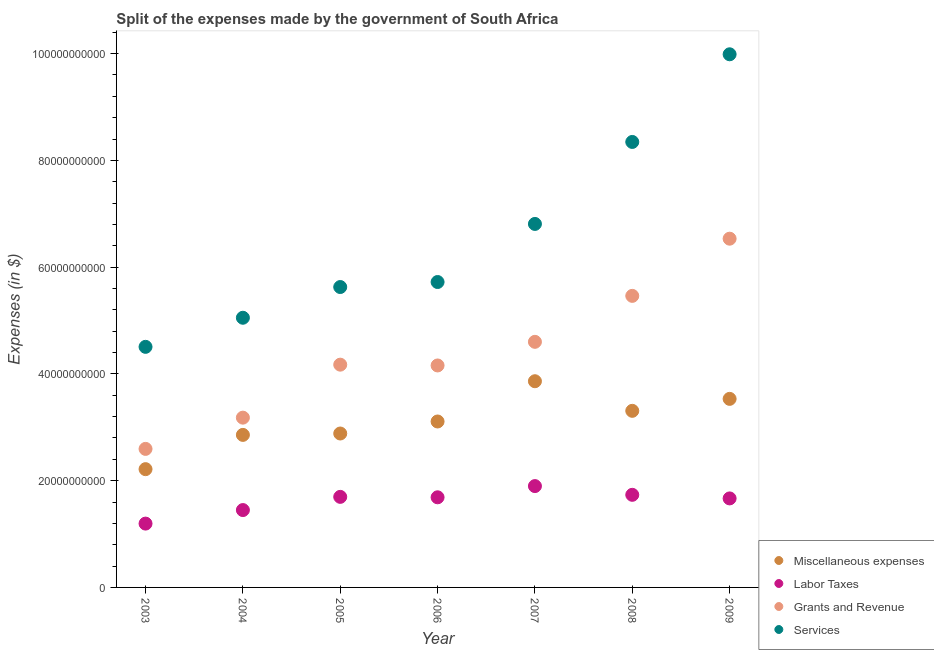How many different coloured dotlines are there?
Keep it short and to the point. 4. Is the number of dotlines equal to the number of legend labels?
Keep it short and to the point. Yes. What is the amount spent on miscellaneous expenses in 2005?
Keep it short and to the point. 2.88e+1. Across all years, what is the maximum amount spent on labor taxes?
Offer a terse response. 1.90e+1. Across all years, what is the minimum amount spent on labor taxes?
Make the answer very short. 1.20e+1. What is the total amount spent on grants and revenue in the graph?
Your answer should be very brief. 3.07e+11. What is the difference between the amount spent on labor taxes in 2004 and that in 2008?
Offer a terse response. -2.86e+09. What is the difference between the amount spent on miscellaneous expenses in 2003 and the amount spent on grants and revenue in 2004?
Offer a terse response. -9.65e+09. What is the average amount spent on services per year?
Offer a terse response. 6.58e+1. In the year 2005, what is the difference between the amount spent on grants and revenue and amount spent on services?
Your answer should be compact. -1.45e+1. In how many years, is the amount spent on grants and revenue greater than 64000000000 $?
Provide a short and direct response. 1. What is the ratio of the amount spent on grants and revenue in 2008 to that in 2009?
Ensure brevity in your answer.  0.84. What is the difference between the highest and the second highest amount spent on miscellaneous expenses?
Provide a short and direct response. 3.30e+09. What is the difference between the highest and the lowest amount spent on miscellaneous expenses?
Keep it short and to the point. 1.65e+1. Is the sum of the amount spent on miscellaneous expenses in 2003 and 2006 greater than the maximum amount spent on labor taxes across all years?
Keep it short and to the point. Yes. Is it the case that in every year, the sum of the amount spent on miscellaneous expenses and amount spent on labor taxes is greater than the amount spent on grants and revenue?
Give a very brief answer. No. Does the amount spent on labor taxes monotonically increase over the years?
Provide a succinct answer. No. Is the amount spent on services strictly greater than the amount spent on grants and revenue over the years?
Provide a succinct answer. Yes. Is the amount spent on labor taxes strictly less than the amount spent on services over the years?
Make the answer very short. Yes. How many dotlines are there?
Your answer should be very brief. 4. How many years are there in the graph?
Ensure brevity in your answer.  7. Does the graph contain any zero values?
Keep it short and to the point. No. Does the graph contain grids?
Keep it short and to the point. No. Where does the legend appear in the graph?
Your answer should be very brief. Bottom right. How many legend labels are there?
Your answer should be very brief. 4. How are the legend labels stacked?
Your response must be concise. Vertical. What is the title of the graph?
Make the answer very short. Split of the expenses made by the government of South Africa. What is the label or title of the X-axis?
Provide a short and direct response. Year. What is the label or title of the Y-axis?
Provide a succinct answer. Expenses (in $). What is the Expenses (in $) in Miscellaneous expenses in 2003?
Ensure brevity in your answer.  2.22e+1. What is the Expenses (in $) in Labor Taxes in 2003?
Offer a terse response. 1.20e+1. What is the Expenses (in $) of Grants and Revenue in 2003?
Give a very brief answer. 2.60e+1. What is the Expenses (in $) of Services in 2003?
Your answer should be compact. 4.51e+1. What is the Expenses (in $) in Miscellaneous expenses in 2004?
Your answer should be very brief. 2.86e+1. What is the Expenses (in $) of Labor Taxes in 2004?
Offer a very short reply. 1.45e+1. What is the Expenses (in $) in Grants and Revenue in 2004?
Your answer should be very brief. 3.18e+1. What is the Expenses (in $) of Services in 2004?
Your answer should be compact. 5.05e+1. What is the Expenses (in $) in Miscellaneous expenses in 2005?
Provide a short and direct response. 2.88e+1. What is the Expenses (in $) of Labor Taxes in 2005?
Ensure brevity in your answer.  1.70e+1. What is the Expenses (in $) in Grants and Revenue in 2005?
Provide a short and direct response. 4.17e+1. What is the Expenses (in $) in Services in 2005?
Your answer should be compact. 5.63e+1. What is the Expenses (in $) in Miscellaneous expenses in 2006?
Give a very brief answer. 3.11e+1. What is the Expenses (in $) in Labor Taxes in 2006?
Give a very brief answer. 1.69e+1. What is the Expenses (in $) of Grants and Revenue in 2006?
Your answer should be very brief. 4.16e+1. What is the Expenses (in $) in Services in 2006?
Give a very brief answer. 5.72e+1. What is the Expenses (in $) in Miscellaneous expenses in 2007?
Offer a very short reply. 3.86e+1. What is the Expenses (in $) in Labor Taxes in 2007?
Offer a very short reply. 1.90e+1. What is the Expenses (in $) in Grants and Revenue in 2007?
Your answer should be compact. 4.60e+1. What is the Expenses (in $) in Services in 2007?
Provide a short and direct response. 6.81e+1. What is the Expenses (in $) of Miscellaneous expenses in 2008?
Offer a terse response. 3.31e+1. What is the Expenses (in $) in Labor Taxes in 2008?
Provide a succinct answer. 1.73e+1. What is the Expenses (in $) of Grants and Revenue in 2008?
Give a very brief answer. 5.46e+1. What is the Expenses (in $) in Services in 2008?
Ensure brevity in your answer.  8.35e+1. What is the Expenses (in $) of Miscellaneous expenses in 2009?
Your answer should be compact. 3.53e+1. What is the Expenses (in $) of Labor Taxes in 2009?
Provide a short and direct response. 1.67e+1. What is the Expenses (in $) of Grants and Revenue in 2009?
Your response must be concise. 6.53e+1. What is the Expenses (in $) in Services in 2009?
Your answer should be very brief. 9.99e+1. Across all years, what is the maximum Expenses (in $) of Miscellaneous expenses?
Provide a short and direct response. 3.86e+1. Across all years, what is the maximum Expenses (in $) in Labor Taxes?
Provide a succinct answer. 1.90e+1. Across all years, what is the maximum Expenses (in $) in Grants and Revenue?
Your answer should be compact. 6.53e+1. Across all years, what is the maximum Expenses (in $) of Services?
Offer a terse response. 9.99e+1. Across all years, what is the minimum Expenses (in $) of Miscellaneous expenses?
Keep it short and to the point. 2.22e+1. Across all years, what is the minimum Expenses (in $) of Labor Taxes?
Ensure brevity in your answer.  1.20e+1. Across all years, what is the minimum Expenses (in $) of Grants and Revenue?
Offer a terse response. 2.60e+1. Across all years, what is the minimum Expenses (in $) in Services?
Offer a very short reply. 4.51e+1. What is the total Expenses (in $) of Miscellaneous expenses in the graph?
Provide a short and direct response. 2.18e+11. What is the total Expenses (in $) in Labor Taxes in the graph?
Your answer should be very brief. 1.13e+11. What is the total Expenses (in $) of Grants and Revenue in the graph?
Your response must be concise. 3.07e+11. What is the total Expenses (in $) of Services in the graph?
Your response must be concise. 4.61e+11. What is the difference between the Expenses (in $) in Miscellaneous expenses in 2003 and that in 2004?
Provide a short and direct response. -6.42e+09. What is the difference between the Expenses (in $) in Labor Taxes in 2003 and that in 2004?
Ensure brevity in your answer.  -2.54e+09. What is the difference between the Expenses (in $) of Grants and Revenue in 2003 and that in 2004?
Your answer should be compact. -5.85e+09. What is the difference between the Expenses (in $) of Services in 2003 and that in 2004?
Your answer should be very brief. -5.45e+09. What is the difference between the Expenses (in $) of Miscellaneous expenses in 2003 and that in 2005?
Offer a very short reply. -6.68e+09. What is the difference between the Expenses (in $) in Labor Taxes in 2003 and that in 2005?
Keep it short and to the point. -5.01e+09. What is the difference between the Expenses (in $) of Grants and Revenue in 2003 and that in 2005?
Provide a succinct answer. -1.58e+1. What is the difference between the Expenses (in $) of Services in 2003 and that in 2005?
Provide a short and direct response. -1.12e+1. What is the difference between the Expenses (in $) in Miscellaneous expenses in 2003 and that in 2006?
Provide a succinct answer. -8.93e+09. What is the difference between the Expenses (in $) of Labor Taxes in 2003 and that in 2006?
Your answer should be compact. -4.93e+09. What is the difference between the Expenses (in $) in Grants and Revenue in 2003 and that in 2006?
Ensure brevity in your answer.  -1.56e+1. What is the difference between the Expenses (in $) in Services in 2003 and that in 2006?
Keep it short and to the point. -1.21e+1. What is the difference between the Expenses (in $) in Miscellaneous expenses in 2003 and that in 2007?
Ensure brevity in your answer.  -1.65e+1. What is the difference between the Expenses (in $) in Labor Taxes in 2003 and that in 2007?
Keep it short and to the point. -7.03e+09. What is the difference between the Expenses (in $) of Grants and Revenue in 2003 and that in 2007?
Give a very brief answer. -2.01e+1. What is the difference between the Expenses (in $) of Services in 2003 and that in 2007?
Make the answer very short. -2.30e+1. What is the difference between the Expenses (in $) in Miscellaneous expenses in 2003 and that in 2008?
Ensure brevity in your answer.  -1.09e+1. What is the difference between the Expenses (in $) in Labor Taxes in 2003 and that in 2008?
Provide a succinct answer. -5.39e+09. What is the difference between the Expenses (in $) in Grants and Revenue in 2003 and that in 2008?
Offer a very short reply. -2.87e+1. What is the difference between the Expenses (in $) in Services in 2003 and that in 2008?
Your answer should be compact. -3.84e+1. What is the difference between the Expenses (in $) of Miscellaneous expenses in 2003 and that in 2009?
Give a very brief answer. -1.32e+1. What is the difference between the Expenses (in $) of Labor Taxes in 2003 and that in 2009?
Make the answer very short. -4.72e+09. What is the difference between the Expenses (in $) in Grants and Revenue in 2003 and that in 2009?
Ensure brevity in your answer.  -3.94e+1. What is the difference between the Expenses (in $) of Services in 2003 and that in 2009?
Your answer should be compact. -5.48e+1. What is the difference between the Expenses (in $) in Miscellaneous expenses in 2004 and that in 2005?
Make the answer very short. -2.61e+08. What is the difference between the Expenses (in $) in Labor Taxes in 2004 and that in 2005?
Offer a terse response. -2.47e+09. What is the difference between the Expenses (in $) of Grants and Revenue in 2004 and that in 2005?
Give a very brief answer. -9.93e+09. What is the difference between the Expenses (in $) of Services in 2004 and that in 2005?
Offer a very short reply. -5.76e+09. What is the difference between the Expenses (in $) in Miscellaneous expenses in 2004 and that in 2006?
Provide a short and direct response. -2.51e+09. What is the difference between the Expenses (in $) in Labor Taxes in 2004 and that in 2006?
Keep it short and to the point. -2.39e+09. What is the difference between the Expenses (in $) in Grants and Revenue in 2004 and that in 2006?
Offer a terse response. -9.78e+09. What is the difference between the Expenses (in $) in Services in 2004 and that in 2006?
Your answer should be compact. -6.70e+09. What is the difference between the Expenses (in $) in Miscellaneous expenses in 2004 and that in 2007?
Your answer should be compact. -1.01e+1. What is the difference between the Expenses (in $) of Labor Taxes in 2004 and that in 2007?
Your answer should be very brief. -4.49e+09. What is the difference between the Expenses (in $) of Grants and Revenue in 2004 and that in 2007?
Your answer should be compact. -1.42e+1. What is the difference between the Expenses (in $) of Services in 2004 and that in 2007?
Provide a succinct answer. -1.76e+1. What is the difference between the Expenses (in $) in Miscellaneous expenses in 2004 and that in 2008?
Your answer should be compact. -4.51e+09. What is the difference between the Expenses (in $) in Labor Taxes in 2004 and that in 2008?
Give a very brief answer. -2.86e+09. What is the difference between the Expenses (in $) of Grants and Revenue in 2004 and that in 2008?
Offer a very short reply. -2.28e+1. What is the difference between the Expenses (in $) of Services in 2004 and that in 2008?
Provide a short and direct response. -3.29e+1. What is the difference between the Expenses (in $) of Miscellaneous expenses in 2004 and that in 2009?
Your answer should be compact. -6.75e+09. What is the difference between the Expenses (in $) of Labor Taxes in 2004 and that in 2009?
Your response must be concise. -2.18e+09. What is the difference between the Expenses (in $) of Grants and Revenue in 2004 and that in 2009?
Provide a short and direct response. -3.35e+1. What is the difference between the Expenses (in $) of Services in 2004 and that in 2009?
Provide a succinct answer. -4.94e+1. What is the difference between the Expenses (in $) in Miscellaneous expenses in 2005 and that in 2006?
Offer a very short reply. -2.25e+09. What is the difference between the Expenses (in $) of Labor Taxes in 2005 and that in 2006?
Provide a succinct answer. 8.20e+07. What is the difference between the Expenses (in $) of Grants and Revenue in 2005 and that in 2006?
Your answer should be very brief. 1.50e+08. What is the difference between the Expenses (in $) in Services in 2005 and that in 2006?
Make the answer very short. -9.39e+08. What is the difference between the Expenses (in $) of Miscellaneous expenses in 2005 and that in 2007?
Your response must be concise. -9.79e+09. What is the difference between the Expenses (in $) in Labor Taxes in 2005 and that in 2007?
Your answer should be very brief. -2.02e+09. What is the difference between the Expenses (in $) of Grants and Revenue in 2005 and that in 2007?
Keep it short and to the point. -4.28e+09. What is the difference between the Expenses (in $) of Services in 2005 and that in 2007?
Offer a terse response. -1.18e+1. What is the difference between the Expenses (in $) of Miscellaneous expenses in 2005 and that in 2008?
Offer a terse response. -4.25e+09. What is the difference between the Expenses (in $) in Labor Taxes in 2005 and that in 2008?
Keep it short and to the point. -3.83e+08. What is the difference between the Expenses (in $) of Grants and Revenue in 2005 and that in 2008?
Provide a short and direct response. -1.29e+1. What is the difference between the Expenses (in $) in Services in 2005 and that in 2008?
Provide a succinct answer. -2.72e+1. What is the difference between the Expenses (in $) in Miscellaneous expenses in 2005 and that in 2009?
Keep it short and to the point. -6.49e+09. What is the difference between the Expenses (in $) of Labor Taxes in 2005 and that in 2009?
Make the answer very short. 2.91e+08. What is the difference between the Expenses (in $) in Grants and Revenue in 2005 and that in 2009?
Provide a succinct answer. -2.36e+1. What is the difference between the Expenses (in $) in Services in 2005 and that in 2009?
Offer a very short reply. -4.36e+1. What is the difference between the Expenses (in $) of Miscellaneous expenses in 2006 and that in 2007?
Your answer should be very brief. -7.54e+09. What is the difference between the Expenses (in $) of Labor Taxes in 2006 and that in 2007?
Provide a short and direct response. -2.10e+09. What is the difference between the Expenses (in $) of Grants and Revenue in 2006 and that in 2007?
Provide a short and direct response. -4.43e+09. What is the difference between the Expenses (in $) in Services in 2006 and that in 2007?
Keep it short and to the point. -1.09e+1. What is the difference between the Expenses (in $) of Miscellaneous expenses in 2006 and that in 2008?
Your response must be concise. -2.00e+09. What is the difference between the Expenses (in $) in Labor Taxes in 2006 and that in 2008?
Provide a succinct answer. -4.65e+08. What is the difference between the Expenses (in $) of Grants and Revenue in 2006 and that in 2008?
Your answer should be compact. -1.30e+1. What is the difference between the Expenses (in $) in Services in 2006 and that in 2008?
Ensure brevity in your answer.  -2.62e+1. What is the difference between the Expenses (in $) in Miscellaneous expenses in 2006 and that in 2009?
Give a very brief answer. -4.24e+09. What is the difference between the Expenses (in $) of Labor Taxes in 2006 and that in 2009?
Offer a very short reply. 2.09e+08. What is the difference between the Expenses (in $) of Grants and Revenue in 2006 and that in 2009?
Your answer should be compact. -2.37e+1. What is the difference between the Expenses (in $) in Services in 2006 and that in 2009?
Your response must be concise. -4.27e+1. What is the difference between the Expenses (in $) in Miscellaneous expenses in 2007 and that in 2008?
Ensure brevity in your answer.  5.55e+09. What is the difference between the Expenses (in $) in Labor Taxes in 2007 and that in 2008?
Keep it short and to the point. 1.64e+09. What is the difference between the Expenses (in $) in Grants and Revenue in 2007 and that in 2008?
Ensure brevity in your answer.  -8.61e+09. What is the difference between the Expenses (in $) of Services in 2007 and that in 2008?
Offer a terse response. -1.54e+1. What is the difference between the Expenses (in $) in Miscellaneous expenses in 2007 and that in 2009?
Your response must be concise. 3.30e+09. What is the difference between the Expenses (in $) of Labor Taxes in 2007 and that in 2009?
Offer a very short reply. 2.31e+09. What is the difference between the Expenses (in $) of Grants and Revenue in 2007 and that in 2009?
Provide a succinct answer. -1.93e+1. What is the difference between the Expenses (in $) of Services in 2007 and that in 2009?
Offer a very short reply. -3.18e+1. What is the difference between the Expenses (in $) in Miscellaneous expenses in 2008 and that in 2009?
Your answer should be compact. -2.24e+09. What is the difference between the Expenses (in $) in Labor Taxes in 2008 and that in 2009?
Your response must be concise. 6.74e+08. What is the difference between the Expenses (in $) of Grants and Revenue in 2008 and that in 2009?
Provide a succinct answer. -1.07e+1. What is the difference between the Expenses (in $) of Services in 2008 and that in 2009?
Provide a succinct answer. -1.64e+1. What is the difference between the Expenses (in $) in Miscellaneous expenses in 2003 and the Expenses (in $) in Labor Taxes in 2004?
Your answer should be very brief. 7.66e+09. What is the difference between the Expenses (in $) in Miscellaneous expenses in 2003 and the Expenses (in $) in Grants and Revenue in 2004?
Ensure brevity in your answer.  -9.65e+09. What is the difference between the Expenses (in $) in Miscellaneous expenses in 2003 and the Expenses (in $) in Services in 2004?
Give a very brief answer. -2.84e+1. What is the difference between the Expenses (in $) of Labor Taxes in 2003 and the Expenses (in $) of Grants and Revenue in 2004?
Offer a terse response. -1.98e+1. What is the difference between the Expenses (in $) in Labor Taxes in 2003 and the Expenses (in $) in Services in 2004?
Make the answer very short. -3.86e+1. What is the difference between the Expenses (in $) in Grants and Revenue in 2003 and the Expenses (in $) in Services in 2004?
Make the answer very short. -2.46e+1. What is the difference between the Expenses (in $) in Miscellaneous expenses in 2003 and the Expenses (in $) in Labor Taxes in 2005?
Your answer should be compact. 5.19e+09. What is the difference between the Expenses (in $) of Miscellaneous expenses in 2003 and the Expenses (in $) of Grants and Revenue in 2005?
Keep it short and to the point. -1.96e+1. What is the difference between the Expenses (in $) of Miscellaneous expenses in 2003 and the Expenses (in $) of Services in 2005?
Your response must be concise. -3.41e+1. What is the difference between the Expenses (in $) of Labor Taxes in 2003 and the Expenses (in $) of Grants and Revenue in 2005?
Keep it short and to the point. -2.98e+1. What is the difference between the Expenses (in $) in Labor Taxes in 2003 and the Expenses (in $) in Services in 2005?
Your answer should be compact. -4.43e+1. What is the difference between the Expenses (in $) in Grants and Revenue in 2003 and the Expenses (in $) in Services in 2005?
Keep it short and to the point. -3.03e+1. What is the difference between the Expenses (in $) of Miscellaneous expenses in 2003 and the Expenses (in $) of Labor Taxes in 2006?
Make the answer very short. 5.27e+09. What is the difference between the Expenses (in $) of Miscellaneous expenses in 2003 and the Expenses (in $) of Grants and Revenue in 2006?
Your answer should be very brief. -1.94e+1. What is the difference between the Expenses (in $) in Miscellaneous expenses in 2003 and the Expenses (in $) in Services in 2006?
Your response must be concise. -3.51e+1. What is the difference between the Expenses (in $) of Labor Taxes in 2003 and the Expenses (in $) of Grants and Revenue in 2006?
Ensure brevity in your answer.  -2.96e+1. What is the difference between the Expenses (in $) of Labor Taxes in 2003 and the Expenses (in $) of Services in 2006?
Keep it short and to the point. -4.53e+1. What is the difference between the Expenses (in $) in Grants and Revenue in 2003 and the Expenses (in $) in Services in 2006?
Your answer should be very brief. -3.13e+1. What is the difference between the Expenses (in $) of Miscellaneous expenses in 2003 and the Expenses (in $) of Labor Taxes in 2007?
Your response must be concise. 3.17e+09. What is the difference between the Expenses (in $) of Miscellaneous expenses in 2003 and the Expenses (in $) of Grants and Revenue in 2007?
Your answer should be very brief. -2.39e+1. What is the difference between the Expenses (in $) in Miscellaneous expenses in 2003 and the Expenses (in $) in Services in 2007?
Make the answer very short. -4.59e+1. What is the difference between the Expenses (in $) of Labor Taxes in 2003 and the Expenses (in $) of Grants and Revenue in 2007?
Keep it short and to the point. -3.41e+1. What is the difference between the Expenses (in $) in Labor Taxes in 2003 and the Expenses (in $) in Services in 2007?
Your response must be concise. -5.61e+1. What is the difference between the Expenses (in $) of Grants and Revenue in 2003 and the Expenses (in $) of Services in 2007?
Ensure brevity in your answer.  -4.21e+1. What is the difference between the Expenses (in $) in Miscellaneous expenses in 2003 and the Expenses (in $) in Labor Taxes in 2008?
Provide a succinct answer. 4.81e+09. What is the difference between the Expenses (in $) in Miscellaneous expenses in 2003 and the Expenses (in $) in Grants and Revenue in 2008?
Keep it short and to the point. -3.25e+1. What is the difference between the Expenses (in $) in Miscellaneous expenses in 2003 and the Expenses (in $) in Services in 2008?
Ensure brevity in your answer.  -6.13e+1. What is the difference between the Expenses (in $) in Labor Taxes in 2003 and the Expenses (in $) in Grants and Revenue in 2008?
Your response must be concise. -4.27e+1. What is the difference between the Expenses (in $) of Labor Taxes in 2003 and the Expenses (in $) of Services in 2008?
Ensure brevity in your answer.  -7.15e+1. What is the difference between the Expenses (in $) in Grants and Revenue in 2003 and the Expenses (in $) in Services in 2008?
Your answer should be very brief. -5.75e+1. What is the difference between the Expenses (in $) in Miscellaneous expenses in 2003 and the Expenses (in $) in Labor Taxes in 2009?
Provide a succinct answer. 5.48e+09. What is the difference between the Expenses (in $) of Miscellaneous expenses in 2003 and the Expenses (in $) of Grants and Revenue in 2009?
Ensure brevity in your answer.  -4.32e+1. What is the difference between the Expenses (in $) of Miscellaneous expenses in 2003 and the Expenses (in $) of Services in 2009?
Ensure brevity in your answer.  -7.77e+1. What is the difference between the Expenses (in $) in Labor Taxes in 2003 and the Expenses (in $) in Grants and Revenue in 2009?
Provide a succinct answer. -5.34e+1. What is the difference between the Expenses (in $) in Labor Taxes in 2003 and the Expenses (in $) in Services in 2009?
Give a very brief answer. -8.79e+1. What is the difference between the Expenses (in $) in Grants and Revenue in 2003 and the Expenses (in $) in Services in 2009?
Your response must be concise. -7.39e+1. What is the difference between the Expenses (in $) of Miscellaneous expenses in 2004 and the Expenses (in $) of Labor Taxes in 2005?
Your response must be concise. 1.16e+1. What is the difference between the Expenses (in $) in Miscellaneous expenses in 2004 and the Expenses (in $) in Grants and Revenue in 2005?
Your response must be concise. -1.32e+1. What is the difference between the Expenses (in $) in Miscellaneous expenses in 2004 and the Expenses (in $) in Services in 2005?
Offer a terse response. -2.77e+1. What is the difference between the Expenses (in $) in Labor Taxes in 2004 and the Expenses (in $) in Grants and Revenue in 2005?
Your answer should be compact. -2.72e+1. What is the difference between the Expenses (in $) in Labor Taxes in 2004 and the Expenses (in $) in Services in 2005?
Your answer should be very brief. -4.18e+1. What is the difference between the Expenses (in $) of Grants and Revenue in 2004 and the Expenses (in $) of Services in 2005?
Keep it short and to the point. -2.45e+1. What is the difference between the Expenses (in $) of Miscellaneous expenses in 2004 and the Expenses (in $) of Labor Taxes in 2006?
Give a very brief answer. 1.17e+1. What is the difference between the Expenses (in $) in Miscellaneous expenses in 2004 and the Expenses (in $) in Grants and Revenue in 2006?
Make the answer very short. -1.30e+1. What is the difference between the Expenses (in $) in Miscellaneous expenses in 2004 and the Expenses (in $) in Services in 2006?
Your answer should be compact. -2.86e+1. What is the difference between the Expenses (in $) in Labor Taxes in 2004 and the Expenses (in $) in Grants and Revenue in 2006?
Offer a very short reply. -2.71e+1. What is the difference between the Expenses (in $) in Labor Taxes in 2004 and the Expenses (in $) in Services in 2006?
Your answer should be compact. -4.27e+1. What is the difference between the Expenses (in $) in Grants and Revenue in 2004 and the Expenses (in $) in Services in 2006?
Offer a very short reply. -2.54e+1. What is the difference between the Expenses (in $) in Miscellaneous expenses in 2004 and the Expenses (in $) in Labor Taxes in 2007?
Your answer should be very brief. 9.59e+09. What is the difference between the Expenses (in $) of Miscellaneous expenses in 2004 and the Expenses (in $) of Grants and Revenue in 2007?
Provide a short and direct response. -1.74e+1. What is the difference between the Expenses (in $) of Miscellaneous expenses in 2004 and the Expenses (in $) of Services in 2007?
Offer a terse response. -3.95e+1. What is the difference between the Expenses (in $) in Labor Taxes in 2004 and the Expenses (in $) in Grants and Revenue in 2007?
Give a very brief answer. -3.15e+1. What is the difference between the Expenses (in $) of Labor Taxes in 2004 and the Expenses (in $) of Services in 2007?
Your answer should be compact. -5.36e+1. What is the difference between the Expenses (in $) in Grants and Revenue in 2004 and the Expenses (in $) in Services in 2007?
Your response must be concise. -3.63e+1. What is the difference between the Expenses (in $) of Miscellaneous expenses in 2004 and the Expenses (in $) of Labor Taxes in 2008?
Your answer should be compact. 1.12e+1. What is the difference between the Expenses (in $) of Miscellaneous expenses in 2004 and the Expenses (in $) of Grants and Revenue in 2008?
Your response must be concise. -2.60e+1. What is the difference between the Expenses (in $) of Miscellaneous expenses in 2004 and the Expenses (in $) of Services in 2008?
Your response must be concise. -5.49e+1. What is the difference between the Expenses (in $) of Labor Taxes in 2004 and the Expenses (in $) of Grants and Revenue in 2008?
Make the answer very short. -4.01e+1. What is the difference between the Expenses (in $) of Labor Taxes in 2004 and the Expenses (in $) of Services in 2008?
Your response must be concise. -6.90e+1. What is the difference between the Expenses (in $) in Grants and Revenue in 2004 and the Expenses (in $) in Services in 2008?
Your answer should be very brief. -5.16e+1. What is the difference between the Expenses (in $) in Miscellaneous expenses in 2004 and the Expenses (in $) in Labor Taxes in 2009?
Your response must be concise. 1.19e+1. What is the difference between the Expenses (in $) of Miscellaneous expenses in 2004 and the Expenses (in $) of Grants and Revenue in 2009?
Your answer should be very brief. -3.68e+1. What is the difference between the Expenses (in $) in Miscellaneous expenses in 2004 and the Expenses (in $) in Services in 2009?
Your answer should be compact. -7.13e+1. What is the difference between the Expenses (in $) of Labor Taxes in 2004 and the Expenses (in $) of Grants and Revenue in 2009?
Ensure brevity in your answer.  -5.08e+1. What is the difference between the Expenses (in $) of Labor Taxes in 2004 and the Expenses (in $) of Services in 2009?
Provide a short and direct response. -8.54e+1. What is the difference between the Expenses (in $) in Grants and Revenue in 2004 and the Expenses (in $) in Services in 2009?
Make the answer very short. -6.81e+1. What is the difference between the Expenses (in $) in Miscellaneous expenses in 2005 and the Expenses (in $) in Labor Taxes in 2006?
Your response must be concise. 1.20e+1. What is the difference between the Expenses (in $) of Miscellaneous expenses in 2005 and the Expenses (in $) of Grants and Revenue in 2006?
Offer a very short reply. -1.27e+1. What is the difference between the Expenses (in $) in Miscellaneous expenses in 2005 and the Expenses (in $) in Services in 2006?
Your answer should be very brief. -2.84e+1. What is the difference between the Expenses (in $) in Labor Taxes in 2005 and the Expenses (in $) in Grants and Revenue in 2006?
Ensure brevity in your answer.  -2.46e+1. What is the difference between the Expenses (in $) in Labor Taxes in 2005 and the Expenses (in $) in Services in 2006?
Give a very brief answer. -4.02e+1. What is the difference between the Expenses (in $) in Grants and Revenue in 2005 and the Expenses (in $) in Services in 2006?
Ensure brevity in your answer.  -1.55e+1. What is the difference between the Expenses (in $) of Miscellaneous expenses in 2005 and the Expenses (in $) of Labor Taxes in 2007?
Your answer should be very brief. 9.85e+09. What is the difference between the Expenses (in $) of Miscellaneous expenses in 2005 and the Expenses (in $) of Grants and Revenue in 2007?
Your answer should be very brief. -1.72e+1. What is the difference between the Expenses (in $) of Miscellaneous expenses in 2005 and the Expenses (in $) of Services in 2007?
Keep it short and to the point. -3.93e+1. What is the difference between the Expenses (in $) of Labor Taxes in 2005 and the Expenses (in $) of Grants and Revenue in 2007?
Give a very brief answer. -2.90e+1. What is the difference between the Expenses (in $) in Labor Taxes in 2005 and the Expenses (in $) in Services in 2007?
Make the answer very short. -5.11e+1. What is the difference between the Expenses (in $) in Grants and Revenue in 2005 and the Expenses (in $) in Services in 2007?
Give a very brief answer. -2.64e+1. What is the difference between the Expenses (in $) of Miscellaneous expenses in 2005 and the Expenses (in $) of Labor Taxes in 2008?
Your answer should be very brief. 1.15e+1. What is the difference between the Expenses (in $) of Miscellaneous expenses in 2005 and the Expenses (in $) of Grants and Revenue in 2008?
Keep it short and to the point. -2.58e+1. What is the difference between the Expenses (in $) of Miscellaneous expenses in 2005 and the Expenses (in $) of Services in 2008?
Offer a terse response. -5.46e+1. What is the difference between the Expenses (in $) in Labor Taxes in 2005 and the Expenses (in $) in Grants and Revenue in 2008?
Ensure brevity in your answer.  -3.77e+1. What is the difference between the Expenses (in $) of Labor Taxes in 2005 and the Expenses (in $) of Services in 2008?
Offer a very short reply. -6.65e+1. What is the difference between the Expenses (in $) in Grants and Revenue in 2005 and the Expenses (in $) in Services in 2008?
Offer a terse response. -4.17e+1. What is the difference between the Expenses (in $) of Miscellaneous expenses in 2005 and the Expenses (in $) of Labor Taxes in 2009?
Your response must be concise. 1.22e+1. What is the difference between the Expenses (in $) of Miscellaneous expenses in 2005 and the Expenses (in $) of Grants and Revenue in 2009?
Provide a short and direct response. -3.65e+1. What is the difference between the Expenses (in $) of Miscellaneous expenses in 2005 and the Expenses (in $) of Services in 2009?
Offer a terse response. -7.10e+1. What is the difference between the Expenses (in $) of Labor Taxes in 2005 and the Expenses (in $) of Grants and Revenue in 2009?
Your answer should be very brief. -4.84e+1. What is the difference between the Expenses (in $) in Labor Taxes in 2005 and the Expenses (in $) in Services in 2009?
Make the answer very short. -8.29e+1. What is the difference between the Expenses (in $) of Grants and Revenue in 2005 and the Expenses (in $) of Services in 2009?
Provide a succinct answer. -5.81e+1. What is the difference between the Expenses (in $) of Miscellaneous expenses in 2006 and the Expenses (in $) of Labor Taxes in 2007?
Your answer should be compact. 1.21e+1. What is the difference between the Expenses (in $) of Miscellaneous expenses in 2006 and the Expenses (in $) of Grants and Revenue in 2007?
Provide a short and direct response. -1.49e+1. What is the difference between the Expenses (in $) in Miscellaneous expenses in 2006 and the Expenses (in $) in Services in 2007?
Ensure brevity in your answer.  -3.70e+1. What is the difference between the Expenses (in $) in Labor Taxes in 2006 and the Expenses (in $) in Grants and Revenue in 2007?
Ensure brevity in your answer.  -2.91e+1. What is the difference between the Expenses (in $) of Labor Taxes in 2006 and the Expenses (in $) of Services in 2007?
Your answer should be compact. -5.12e+1. What is the difference between the Expenses (in $) of Grants and Revenue in 2006 and the Expenses (in $) of Services in 2007?
Your answer should be compact. -2.65e+1. What is the difference between the Expenses (in $) in Miscellaneous expenses in 2006 and the Expenses (in $) in Labor Taxes in 2008?
Ensure brevity in your answer.  1.37e+1. What is the difference between the Expenses (in $) of Miscellaneous expenses in 2006 and the Expenses (in $) of Grants and Revenue in 2008?
Keep it short and to the point. -2.35e+1. What is the difference between the Expenses (in $) of Miscellaneous expenses in 2006 and the Expenses (in $) of Services in 2008?
Make the answer very short. -5.24e+1. What is the difference between the Expenses (in $) in Labor Taxes in 2006 and the Expenses (in $) in Grants and Revenue in 2008?
Your response must be concise. -3.77e+1. What is the difference between the Expenses (in $) of Labor Taxes in 2006 and the Expenses (in $) of Services in 2008?
Offer a terse response. -6.66e+1. What is the difference between the Expenses (in $) in Grants and Revenue in 2006 and the Expenses (in $) in Services in 2008?
Offer a terse response. -4.19e+1. What is the difference between the Expenses (in $) in Miscellaneous expenses in 2006 and the Expenses (in $) in Labor Taxes in 2009?
Your answer should be very brief. 1.44e+1. What is the difference between the Expenses (in $) of Miscellaneous expenses in 2006 and the Expenses (in $) of Grants and Revenue in 2009?
Ensure brevity in your answer.  -3.42e+1. What is the difference between the Expenses (in $) of Miscellaneous expenses in 2006 and the Expenses (in $) of Services in 2009?
Your answer should be very brief. -6.88e+1. What is the difference between the Expenses (in $) of Labor Taxes in 2006 and the Expenses (in $) of Grants and Revenue in 2009?
Provide a short and direct response. -4.84e+1. What is the difference between the Expenses (in $) in Labor Taxes in 2006 and the Expenses (in $) in Services in 2009?
Offer a terse response. -8.30e+1. What is the difference between the Expenses (in $) of Grants and Revenue in 2006 and the Expenses (in $) of Services in 2009?
Offer a terse response. -5.83e+1. What is the difference between the Expenses (in $) in Miscellaneous expenses in 2007 and the Expenses (in $) in Labor Taxes in 2008?
Your answer should be compact. 2.13e+1. What is the difference between the Expenses (in $) in Miscellaneous expenses in 2007 and the Expenses (in $) in Grants and Revenue in 2008?
Keep it short and to the point. -1.60e+1. What is the difference between the Expenses (in $) in Miscellaneous expenses in 2007 and the Expenses (in $) in Services in 2008?
Ensure brevity in your answer.  -4.48e+1. What is the difference between the Expenses (in $) in Labor Taxes in 2007 and the Expenses (in $) in Grants and Revenue in 2008?
Provide a short and direct response. -3.56e+1. What is the difference between the Expenses (in $) of Labor Taxes in 2007 and the Expenses (in $) of Services in 2008?
Your response must be concise. -6.45e+1. What is the difference between the Expenses (in $) in Grants and Revenue in 2007 and the Expenses (in $) in Services in 2008?
Provide a succinct answer. -3.74e+1. What is the difference between the Expenses (in $) of Miscellaneous expenses in 2007 and the Expenses (in $) of Labor Taxes in 2009?
Your answer should be compact. 2.20e+1. What is the difference between the Expenses (in $) in Miscellaneous expenses in 2007 and the Expenses (in $) in Grants and Revenue in 2009?
Provide a succinct answer. -2.67e+1. What is the difference between the Expenses (in $) of Miscellaneous expenses in 2007 and the Expenses (in $) of Services in 2009?
Keep it short and to the point. -6.12e+1. What is the difference between the Expenses (in $) in Labor Taxes in 2007 and the Expenses (in $) in Grants and Revenue in 2009?
Make the answer very short. -4.63e+1. What is the difference between the Expenses (in $) in Labor Taxes in 2007 and the Expenses (in $) in Services in 2009?
Offer a terse response. -8.09e+1. What is the difference between the Expenses (in $) of Grants and Revenue in 2007 and the Expenses (in $) of Services in 2009?
Offer a very short reply. -5.39e+1. What is the difference between the Expenses (in $) in Miscellaneous expenses in 2008 and the Expenses (in $) in Labor Taxes in 2009?
Ensure brevity in your answer.  1.64e+1. What is the difference between the Expenses (in $) of Miscellaneous expenses in 2008 and the Expenses (in $) of Grants and Revenue in 2009?
Offer a very short reply. -3.22e+1. What is the difference between the Expenses (in $) in Miscellaneous expenses in 2008 and the Expenses (in $) in Services in 2009?
Offer a very short reply. -6.68e+1. What is the difference between the Expenses (in $) of Labor Taxes in 2008 and the Expenses (in $) of Grants and Revenue in 2009?
Offer a terse response. -4.80e+1. What is the difference between the Expenses (in $) in Labor Taxes in 2008 and the Expenses (in $) in Services in 2009?
Your response must be concise. -8.25e+1. What is the difference between the Expenses (in $) of Grants and Revenue in 2008 and the Expenses (in $) of Services in 2009?
Provide a succinct answer. -4.53e+1. What is the average Expenses (in $) of Miscellaneous expenses per year?
Your answer should be compact. 3.11e+1. What is the average Expenses (in $) of Labor Taxes per year?
Your answer should be very brief. 1.62e+1. What is the average Expenses (in $) of Grants and Revenue per year?
Give a very brief answer. 4.39e+1. What is the average Expenses (in $) of Services per year?
Give a very brief answer. 6.58e+1. In the year 2003, what is the difference between the Expenses (in $) in Miscellaneous expenses and Expenses (in $) in Labor Taxes?
Offer a terse response. 1.02e+1. In the year 2003, what is the difference between the Expenses (in $) of Miscellaneous expenses and Expenses (in $) of Grants and Revenue?
Provide a succinct answer. -3.80e+09. In the year 2003, what is the difference between the Expenses (in $) of Miscellaneous expenses and Expenses (in $) of Services?
Your response must be concise. -2.29e+1. In the year 2003, what is the difference between the Expenses (in $) in Labor Taxes and Expenses (in $) in Grants and Revenue?
Keep it short and to the point. -1.40e+1. In the year 2003, what is the difference between the Expenses (in $) of Labor Taxes and Expenses (in $) of Services?
Offer a terse response. -3.31e+1. In the year 2003, what is the difference between the Expenses (in $) in Grants and Revenue and Expenses (in $) in Services?
Offer a very short reply. -1.91e+1. In the year 2004, what is the difference between the Expenses (in $) of Miscellaneous expenses and Expenses (in $) of Labor Taxes?
Offer a very short reply. 1.41e+1. In the year 2004, what is the difference between the Expenses (in $) of Miscellaneous expenses and Expenses (in $) of Grants and Revenue?
Make the answer very short. -3.23e+09. In the year 2004, what is the difference between the Expenses (in $) of Miscellaneous expenses and Expenses (in $) of Services?
Make the answer very short. -2.19e+1. In the year 2004, what is the difference between the Expenses (in $) in Labor Taxes and Expenses (in $) in Grants and Revenue?
Make the answer very short. -1.73e+1. In the year 2004, what is the difference between the Expenses (in $) of Labor Taxes and Expenses (in $) of Services?
Your answer should be compact. -3.60e+1. In the year 2004, what is the difference between the Expenses (in $) in Grants and Revenue and Expenses (in $) in Services?
Provide a short and direct response. -1.87e+1. In the year 2005, what is the difference between the Expenses (in $) in Miscellaneous expenses and Expenses (in $) in Labor Taxes?
Offer a very short reply. 1.19e+1. In the year 2005, what is the difference between the Expenses (in $) in Miscellaneous expenses and Expenses (in $) in Grants and Revenue?
Offer a terse response. -1.29e+1. In the year 2005, what is the difference between the Expenses (in $) of Miscellaneous expenses and Expenses (in $) of Services?
Provide a short and direct response. -2.74e+1. In the year 2005, what is the difference between the Expenses (in $) of Labor Taxes and Expenses (in $) of Grants and Revenue?
Offer a very short reply. -2.48e+1. In the year 2005, what is the difference between the Expenses (in $) of Labor Taxes and Expenses (in $) of Services?
Give a very brief answer. -3.93e+1. In the year 2005, what is the difference between the Expenses (in $) of Grants and Revenue and Expenses (in $) of Services?
Provide a succinct answer. -1.45e+1. In the year 2006, what is the difference between the Expenses (in $) of Miscellaneous expenses and Expenses (in $) of Labor Taxes?
Keep it short and to the point. 1.42e+1. In the year 2006, what is the difference between the Expenses (in $) of Miscellaneous expenses and Expenses (in $) of Grants and Revenue?
Keep it short and to the point. -1.05e+1. In the year 2006, what is the difference between the Expenses (in $) in Miscellaneous expenses and Expenses (in $) in Services?
Make the answer very short. -2.61e+1. In the year 2006, what is the difference between the Expenses (in $) in Labor Taxes and Expenses (in $) in Grants and Revenue?
Offer a terse response. -2.47e+1. In the year 2006, what is the difference between the Expenses (in $) in Labor Taxes and Expenses (in $) in Services?
Your answer should be very brief. -4.03e+1. In the year 2006, what is the difference between the Expenses (in $) of Grants and Revenue and Expenses (in $) of Services?
Ensure brevity in your answer.  -1.56e+1. In the year 2007, what is the difference between the Expenses (in $) in Miscellaneous expenses and Expenses (in $) in Labor Taxes?
Provide a succinct answer. 1.96e+1. In the year 2007, what is the difference between the Expenses (in $) in Miscellaneous expenses and Expenses (in $) in Grants and Revenue?
Your answer should be compact. -7.38e+09. In the year 2007, what is the difference between the Expenses (in $) in Miscellaneous expenses and Expenses (in $) in Services?
Ensure brevity in your answer.  -2.95e+1. In the year 2007, what is the difference between the Expenses (in $) in Labor Taxes and Expenses (in $) in Grants and Revenue?
Your answer should be compact. -2.70e+1. In the year 2007, what is the difference between the Expenses (in $) of Labor Taxes and Expenses (in $) of Services?
Provide a succinct answer. -4.91e+1. In the year 2007, what is the difference between the Expenses (in $) of Grants and Revenue and Expenses (in $) of Services?
Your answer should be compact. -2.21e+1. In the year 2008, what is the difference between the Expenses (in $) in Miscellaneous expenses and Expenses (in $) in Labor Taxes?
Your answer should be very brief. 1.57e+1. In the year 2008, what is the difference between the Expenses (in $) of Miscellaneous expenses and Expenses (in $) of Grants and Revenue?
Offer a terse response. -2.15e+1. In the year 2008, what is the difference between the Expenses (in $) of Miscellaneous expenses and Expenses (in $) of Services?
Give a very brief answer. -5.04e+1. In the year 2008, what is the difference between the Expenses (in $) in Labor Taxes and Expenses (in $) in Grants and Revenue?
Provide a succinct answer. -3.73e+1. In the year 2008, what is the difference between the Expenses (in $) of Labor Taxes and Expenses (in $) of Services?
Your response must be concise. -6.61e+1. In the year 2008, what is the difference between the Expenses (in $) in Grants and Revenue and Expenses (in $) in Services?
Give a very brief answer. -2.88e+1. In the year 2009, what is the difference between the Expenses (in $) of Miscellaneous expenses and Expenses (in $) of Labor Taxes?
Your response must be concise. 1.86e+1. In the year 2009, what is the difference between the Expenses (in $) of Miscellaneous expenses and Expenses (in $) of Grants and Revenue?
Make the answer very short. -3.00e+1. In the year 2009, what is the difference between the Expenses (in $) of Miscellaneous expenses and Expenses (in $) of Services?
Offer a very short reply. -6.46e+1. In the year 2009, what is the difference between the Expenses (in $) in Labor Taxes and Expenses (in $) in Grants and Revenue?
Provide a short and direct response. -4.87e+1. In the year 2009, what is the difference between the Expenses (in $) in Labor Taxes and Expenses (in $) in Services?
Give a very brief answer. -8.32e+1. In the year 2009, what is the difference between the Expenses (in $) in Grants and Revenue and Expenses (in $) in Services?
Offer a terse response. -3.45e+1. What is the ratio of the Expenses (in $) of Miscellaneous expenses in 2003 to that in 2004?
Provide a short and direct response. 0.78. What is the ratio of the Expenses (in $) of Labor Taxes in 2003 to that in 2004?
Your response must be concise. 0.82. What is the ratio of the Expenses (in $) in Grants and Revenue in 2003 to that in 2004?
Ensure brevity in your answer.  0.82. What is the ratio of the Expenses (in $) of Services in 2003 to that in 2004?
Provide a succinct answer. 0.89. What is the ratio of the Expenses (in $) in Miscellaneous expenses in 2003 to that in 2005?
Offer a terse response. 0.77. What is the ratio of the Expenses (in $) of Labor Taxes in 2003 to that in 2005?
Make the answer very short. 0.7. What is the ratio of the Expenses (in $) of Grants and Revenue in 2003 to that in 2005?
Your response must be concise. 0.62. What is the ratio of the Expenses (in $) in Services in 2003 to that in 2005?
Your response must be concise. 0.8. What is the ratio of the Expenses (in $) of Miscellaneous expenses in 2003 to that in 2006?
Give a very brief answer. 0.71. What is the ratio of the Expenses (in $) in Labor Taxes in 2003 to that in 2006?
Your answer should be compact. 0.71. What is the ratio of the Expenses (in $) in Grants and Revenue in 2003 to that in 2006?
Offer a very short reply. 0.62. What is the ratio of the Expenses (in $) of Services in 2003 to that in 2006?
Ensure brevity in your answer.  0.79. What is the ratio of the Expenses (in $) of Miscellaneous expenses in 2003 to that in 2007?
Provide a short and direct response. 0.57. What is the ratio of the Expenses (in $) of Labor Taxes in 2003 to that in 2007?
Your answer should be very brief. 0.63. What is the ratio of the Expenses (in $) in Grants and Revenue in 2003 to that in 2007?
Your response must be concise. 0.56. What is the ratio of the Expenses (in $) in Services in 2003 to that in 2007?
Provide a succinct answer. 0.66. What is the ratio of the Expenses (in $) in Miscellaneous expenses in 2003 to that in 2008?
Your answer should be very brief. 0.67. What is the ratio of the Expenses (in $) of Labor Taxes in 2003 to that in 2008?
Ensure brevity in your answer.  0.69. What is the ratio of the Expenses (in $) of Grants and Revenue in 2003 to that in 2008?
Make the answer very short. 0.48. What is the ratio of the Expenses (in $) of Services in 2003 to that in 2008?
Your answer should be compact. 0.54. What is the ratio of the Expenses (in $) of Miscellaneous expenses in 2003 to that in 2009?
Ensure brevity in your answer.  0.63. What is the ratio of the Expenses (in $) of Labor Taxes in 2003 to that in 2009?
Offer a very short reply. 0.72. What is the ratio of the Expenses (in $) of Grants and Revenue in 2003 to that in 2009?
Offer a terse response. 0.4. What is the ratio of the Expenses (in $) of Services in 2003 to that in 2009?
Your answer should be very brief. 0.45. What is the ratio of the Expenses (in $) of Miscellaneous expenses in 2004 to that in 2005?
Provide a succinct answer. 0.99. What is the ratio of the Expenses (in $) in Labor Taxes in 2004 to that in 2005?
Give a very brief answer. 0.85. What is the ratio of the Expenses (in $) of Grants and Revenue in 2004 to that in 2005?
Give a very brief answer. 0.76. What is the ratio of the Expenses (in $) of Services in 2004 to that in 2005?
Offer a terse response. 0.9. What is the ratio of the Expenses (in $) of Miscellaneous expenses in 2004 to that in 2006?
Your response must be concise. 0.92. What is the ratio of the Expenses (in $) of Labor Taxes in 2004 to that in 2006?
Offer a very short reply. 0.86. What is the ratio of the Expenses (in $) of Grants and Revenue in 2004 to that in 2006?
Make the answer very short. 0.76. What is the ratio of the Expenses (in $) of Services in 2004 to that in 2006?
Ensure brevity in your answer.  0.88. What is the ratio of the Expenses (in $) in Miscellaneous expenses in 2004 to that in 2007?
Make the answer very short. 0.74. What is the ratio of the Expenses (in $) in Labor Taxes in 2004 to that in 2007?
Your response must be concise. 0.76. What is the ratio of the Expenses (in $) in Grants and Revenue in 2004 to that in 2007?
Provide a succinct answer. 0.69. What is the ratio of the Expenses (in $) of Services in 2004 to that in 2007?
Make the answer very short. 0.74. What is the ratio of the Expenses (in $) of Miscellaneous expenses in 2004 to that in 2008?
Keep it short and to the point. 0.86. What is the ratio of the Expenses (in $) of Labor Taxes in 2004 to that in 2008?
Give a very brief answer. 0.84. What is the ratio of the Expenses (in $) in Grants and Revenue in 2004 to that in 2008?
Your response must be concise. 0.58. What is the ratio of the Expenses (in $) in Services in 2004 to that in 2008?
Make the answer very short. 0.61. What is the ratio of the Expenses (in $) in Miscellaneous expenses in 2004 to that in 2009?
Ensure brevity in your answer.  0.81. What is the ratio of the Expenses (in $) of Labor Taxes in 2004 to that in 2009?
Provide a succinct answer. 0.87. What is the ratio of the Expenses (in $) in Grants and Revenue in 2004 to that in 2009?
Your response must be concise. 0.49. What is the ratio of the Expenses (in $) of Services in 2004 to that in 2009?
Ensure brevity in your answer.  0.51. What is the ratio of the Expenses (in $) in Miscellaneous expenses in 2005 to that in 2006?
Provide a succinct answer. 0.93. What is the ratio of the Expenses (in $) in Services in 2005 to that in 2006?
Provide a short and direct response. 0.98. What is the ratio of the Expenses (in $) of Miscellaneous expenses in 2005 to that in 2007?
Your answer should be compact. 0.75. What is the ratio of the Expenses (in $) of Labor Taxes in 2005 to that in 2007?
Provide a succinct answer. 0.89. What is the ratio of the Expenses (in $) in Grants and Revenue in 2005 to that in 2007?
Your response must be concise. 0.91. What is the ratio of the Expenses (in $) in Services in 2005 to that in 2007?
Offer a very short reply. 0.83. What is the ratio of the Expenses (in $) of Miscellaneous expenses in 2005 to that in 2008?
Offer a terse response. 0.87. What is the ratio of the Expenses (in $) of Labor Taxes in 2005 to that in 2008?
Give a very brief answer. 0.98. What is the ratio of the Expenses (in $) in Grants and Revenue in 2005 to that in 2008?
Ensure brevity in your answer.  0.76. What is the ratio of the Expenses (in $) of Services in 2005 to that in 2008?
Your response must be concise. 0.67. What is the ratio of the Expenses (in $) in Miscellaneous expenses in 2005 to that in 2009?
Give a very brief answer. 0.82. What is the ratio of the Expenses (in $) of Labor Taxes in 2005 to that in 2009?
Ensure brevity in your answer.  1.02. What is the ratio of the Expenses (in $) of Grants and Revenue in 2005 to that in 2009?
Make the answer very short. 0.64. What is the ratio of the Expenses (in $) of Services in 2005 to that in 2009?
Give a very brief answer. 0.56. What is the ratio of the Expenses (in $) of Miscellaneous expenses in 2006 to that in 2007?
Provide a succinct answer. 0.8. What is the ratio of the Expenses (in $) of Labor Taxes in 2006 to that in 2007?
Give a very brief answer. 0.89. What is the ratio of the Expenses (in $) of Grants and Revenue in 2006 to that in 2007?
Your answer should be very brief. 0.9. What is the ratio of the Expenses (in $) in Services in 2006 to that in 2007?
Provide a short and direct response. 0.84. What is the ratio of the Expenses (in $) in Miscellaneous expenses in 2006 to that in 2008?
Make the answer very short. 0.94. What is the ratio of the Expenses (in $) of Labor Taxes in 2006 to that in 2008?
Keep it short and to the point. 0.97. What is the ratio of the Expenses (in $) in Grants and Revenue in 2006 to that in 2008?
Offer a terse response. 0.76. What is the ratio of the Expenses (in $) of Services in 2006 to that in 2008?
Ensure brevity in your answer.  0.69. What is the ratio of the Expenses (in $) of Miscellaneous expenses in 2006 to that in 2009?
Your response must be concise. 0.88. What is the ratio of the Expenses (in $) of Labor Taxes in 2006 to that in 2009?
Your response must be concise. 1.01. What is the ratio of the Expenses (in $) in Grants and Revenue in 2006 to that in 2009?
Provide a short and direct response. 0.64. What is the ratio of the Expenses (in $) in Services in 2006 to that in 2009?
Provide a short and direct response. 0.57. What is the ratio of the Expenses (in $) in Miscellaneous expenses in 2007 to that in 2008?
Provide a short and direct response. 1.17. What is the ratio of the Expenses (in $) in Labor Taxes in 2007 to that in 2008?
Offer a terse response. 1.09. What is the ratio of the Expenses (in $) in Grants and Revenue in 2007 to that in 2008?
Give a very brief answer. 0.84. What is the ratio of the Expenses (in $) of Services in 2007 to that in 2008?
Offer a terse response. 0.82. What is the ratio of the Expenses (in $) of Miscellaneous expenses in 2007 to that in 2009?
Provide a succinct answer. 1.09. What is the ratio of the Expenses (in $) in Labor Taxes in 2007 to that in 2009?
Your answer should be very brief. 1.14. What is the ratio of the Expenses (in $) of Grants and Revenue in 2007 to that in 2009?
Your answer should be very brief. 0.7. What is the ratio of the Expenses (in $) in Services in 2007 to that in 2009?
Make the answer very short. 0.68. What is the ratio of the Expenses (in $) in Miscellaneous expenses in 2008 to that in 2009?
Your response must be concise. 0.94. What is the ratio of the Expenses (in $) in Labor Taxes in 2008 to that in 2009?
Your answer should be compact. 1.04. What is the ratio of the Expenses (in $) in Grants and Revenue in 2008 to that in 2009?
Make the answer very short. 0.84. What is the ratio of the Expenses (in $) in Services in 2008 to that in 2009?
Your answer should be compact. 0.84. What is the difference between the highest and the second highest Expenses (in $) in Miscellaneous expenses?
Your answer should be very brief. 3.30e+09. What is the difference between the highest and the second highest Expenses (in $) of Labor Taxes?
Your answer should be compact. 1.64e+09. What is the difference between the highest and the second highest Expenses (in $) of Grants and Revenue?
Offer a very short reply. 1.07e+1. What is the difference between the highest and the second highest Expenses (in $) of Services?
Your response must be concise. 1.64e+1. What is the difference between the highest and the lowest Expenses (in $) of Miscellaneous expenses?
Keep it short and to the point. 1.65e+1. What is the difference between the highest and the lowest Expenses (in $) of Labor Taxes?
Your answer should be very brief. 7.03e+09. What is the difference between the highest and the lowest Expenses (in $) in Grants and Revenue?
Offer a very short reply. 3.94e+1. What is the difference between the highest and the lowest Expenses (in $) of Services?
Your answer should be very brief. 5.48e+1. 